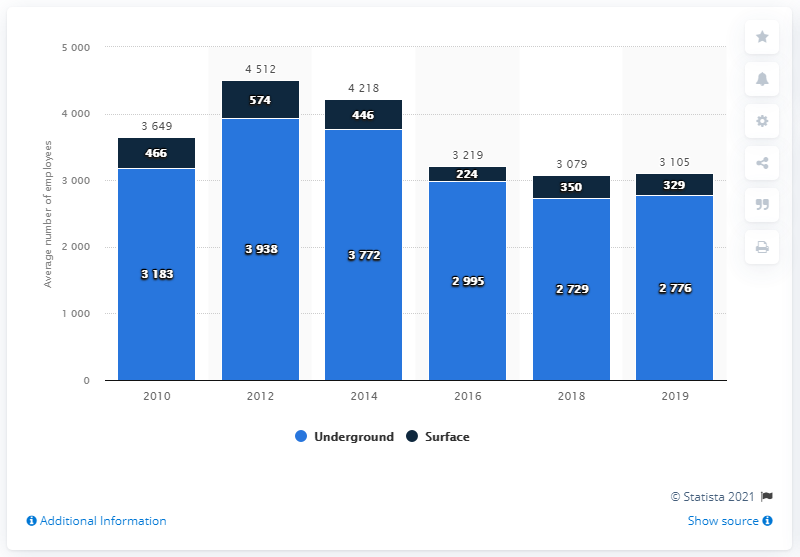Identify some key points in this picture. The difference between the highest and lowest values of the dark blue bar is 350 The lowest value of the light blue bar is 2729. 